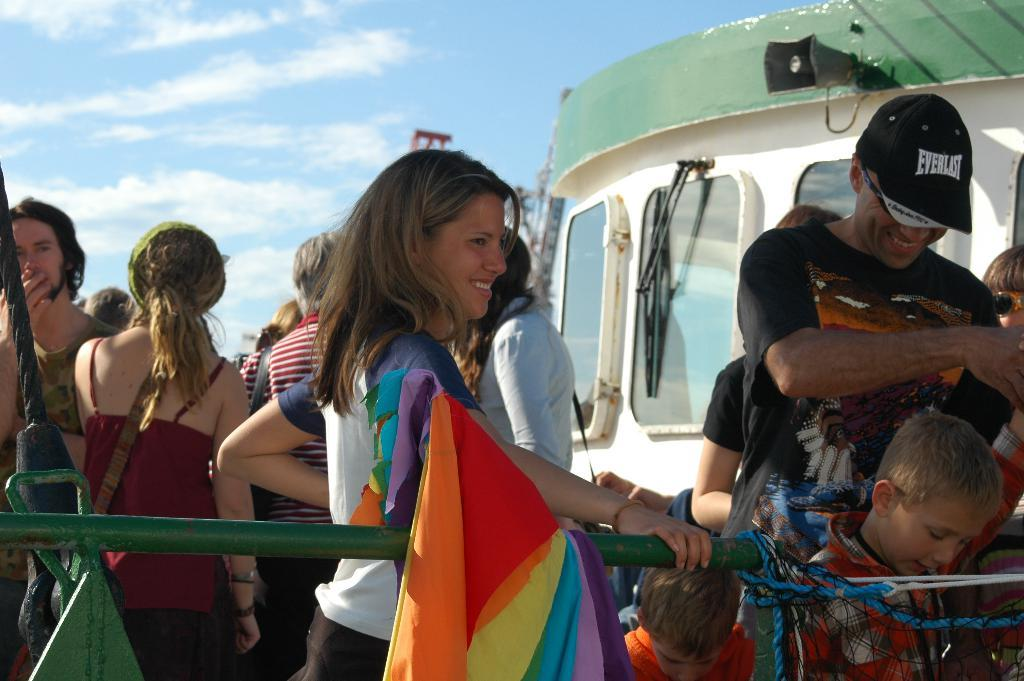What can be seen in the image? There are people standing in the image. Where are the people standing? The people are standing on the floor. What is visible in the background of the image? The sky is visible in the background of the image. What can be observed in the sky? Clouds are present in the sky. Can you see any squirrels in the pocket of the person standing on the left side of the image? There are no squirrels or pockets visible in the image. 